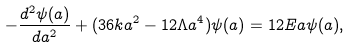<formula> <loc_0><loc_0><loc_500><loc_500>- \frac { d ^ { 2 } \psi ( a ) } { d a ^ { 2 } } + ( 3 6 k a ^ { 2 } - 1 2 \Lambda a ^ { 4 } ) \psi ( a ) = 1 2 E a \psi ( a ) ,</formula> 